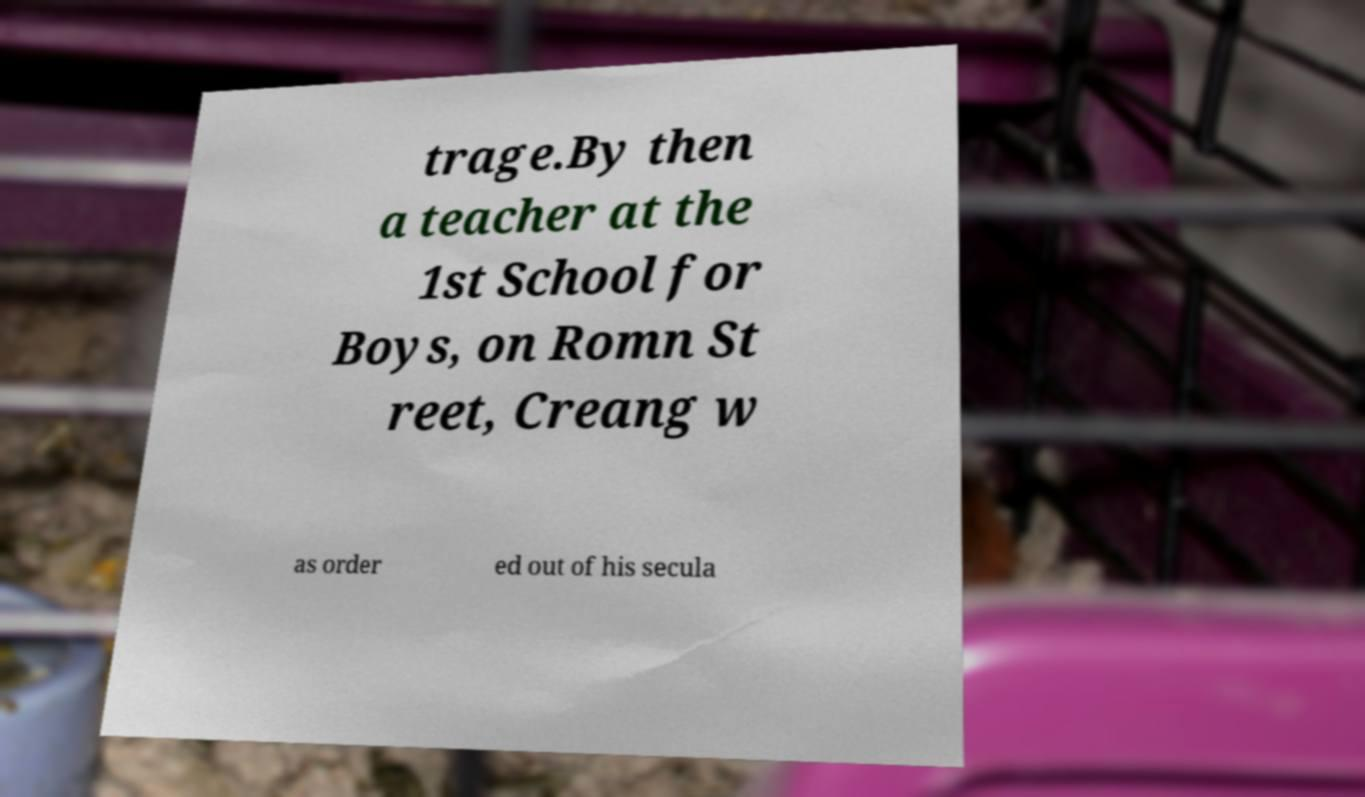For documentation purposes, I need the text within this image transcribed. Could you provide that? trage.By then a teacher at the 1st School for Boys, on Romn St reet, Creang w as order ed out of his secula 